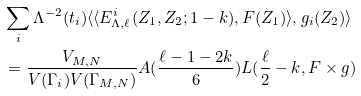<formula> <loc_0><loc_0><loc_500><loc_500>& \sum _ { i } \Lambda ^ { - 2 } ( t _ { i } ) \langle \langle E _ { \Lambda , \ell } ^ { i } ( Z _ { 1 } , Z _ { 2 } ; 1 - k ) , F ( Z _ { 1 } ) \rangle , g _ { i } ( Z _ { 2 } ) \rangle \\ & = \frac { V _ { M , N } } { V ( \Gamma _ { i } ) V ( \Gamma _ { M , N } ) } A ( \frac { \ell - 1 - 2 k } { 6 } ) L ( \frac { \ell } { 2 } - k , F \times g )</formula> 